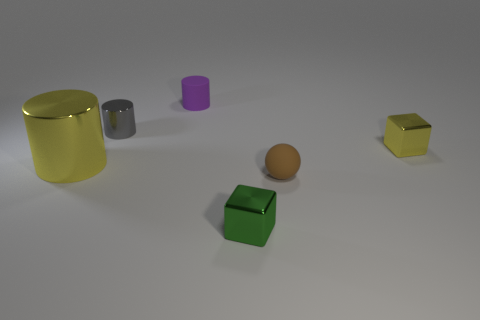What can you infer about the placement of the objects? The objects are scattered across the surface without any apparent order. Their placement seems to be random, with varying distances between each other, giving the scene an unorganized appearance. Does the lighting in the image provide any clues about the setting? The lighting in the image is soft and diffuse, coming from above as evidenced by the subtle shadows each object casts directly beneath it. There are no harsh shadows or high contrasts, suggesting an indoor setting with ambient lighting. 